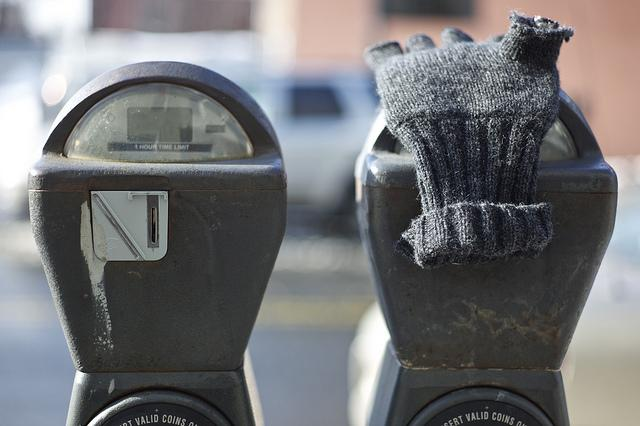What happens if you leave your car parked here an hour and a half?

Choices:
A) bulk rate
B) nothing
C) commendation
D) ticket ticket 